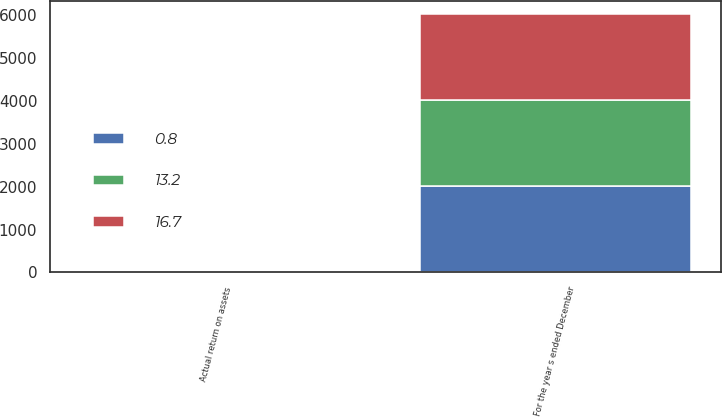Convert chart. <chart><loc_0><loc_0><loc_500><loc_500><stacked_bar_chart><ecel><fcel>For the year s ended December<fcel>Actual return on assets<nl><fcel>16.7<fcel>2013<fcel>16.7<nl><fcel>13.2<fcel>2012<fcel>13.2<nl><fcel>0.8<fcel>2011<fcel>0.8<nl></chart> 